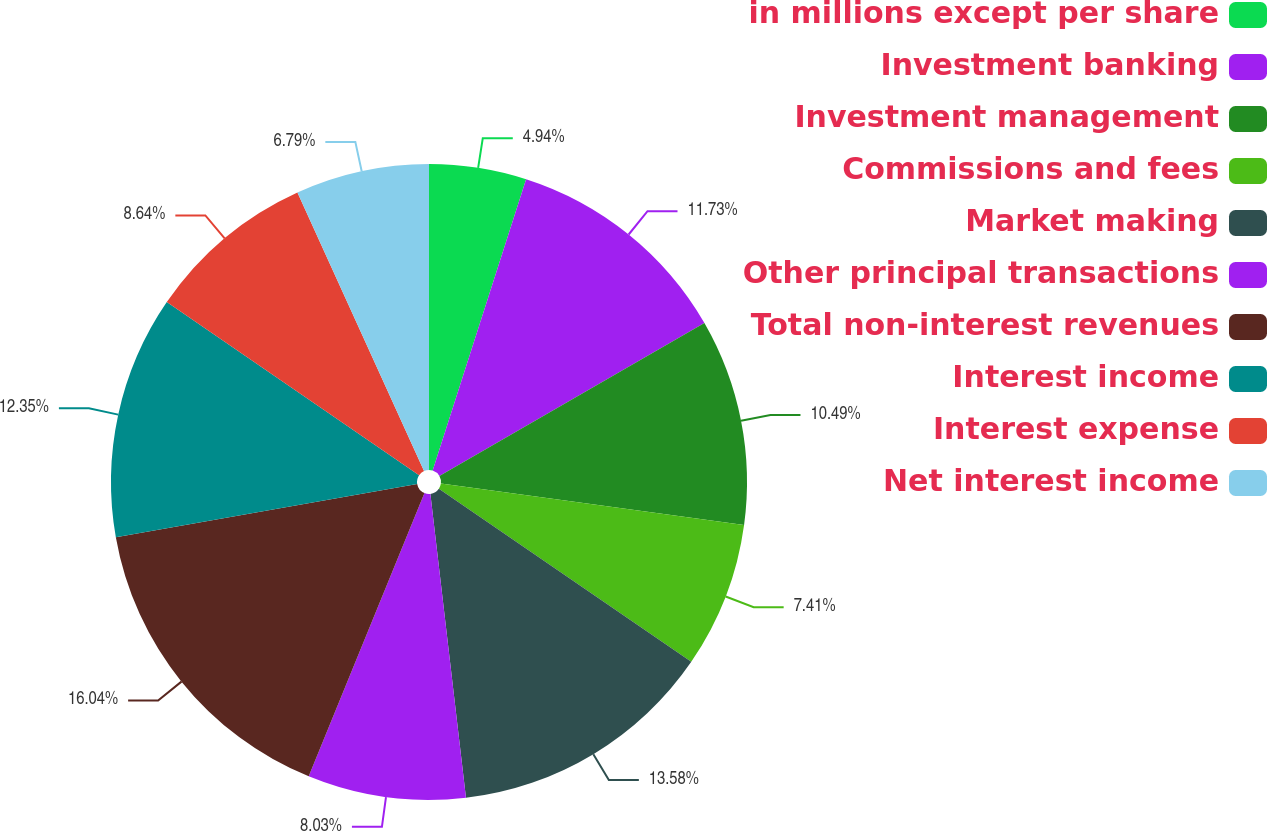Convert chart. <chart><loc_0><loc_0><loc_500><loc_500><pie_chart><fcel>in millions except per share<fcel>Investment banking<fcel>Investment management<fcel>Commissions and fees<fcel>Market making<fcel>Other principal transactions<fcel>Total non-interest revenues<fcel>Interest income<fcel>Interest expense<fcel>Net interest income<nl><fcel>4.94%<fcel>11.73%<fcel>10.49%<fcel>7.41%<fcel>13.58%<fcel>8.03%<fcel>16.05%<fcel>12.35%<fcel>8.64%<fcel>6.79%<nl></chart> 